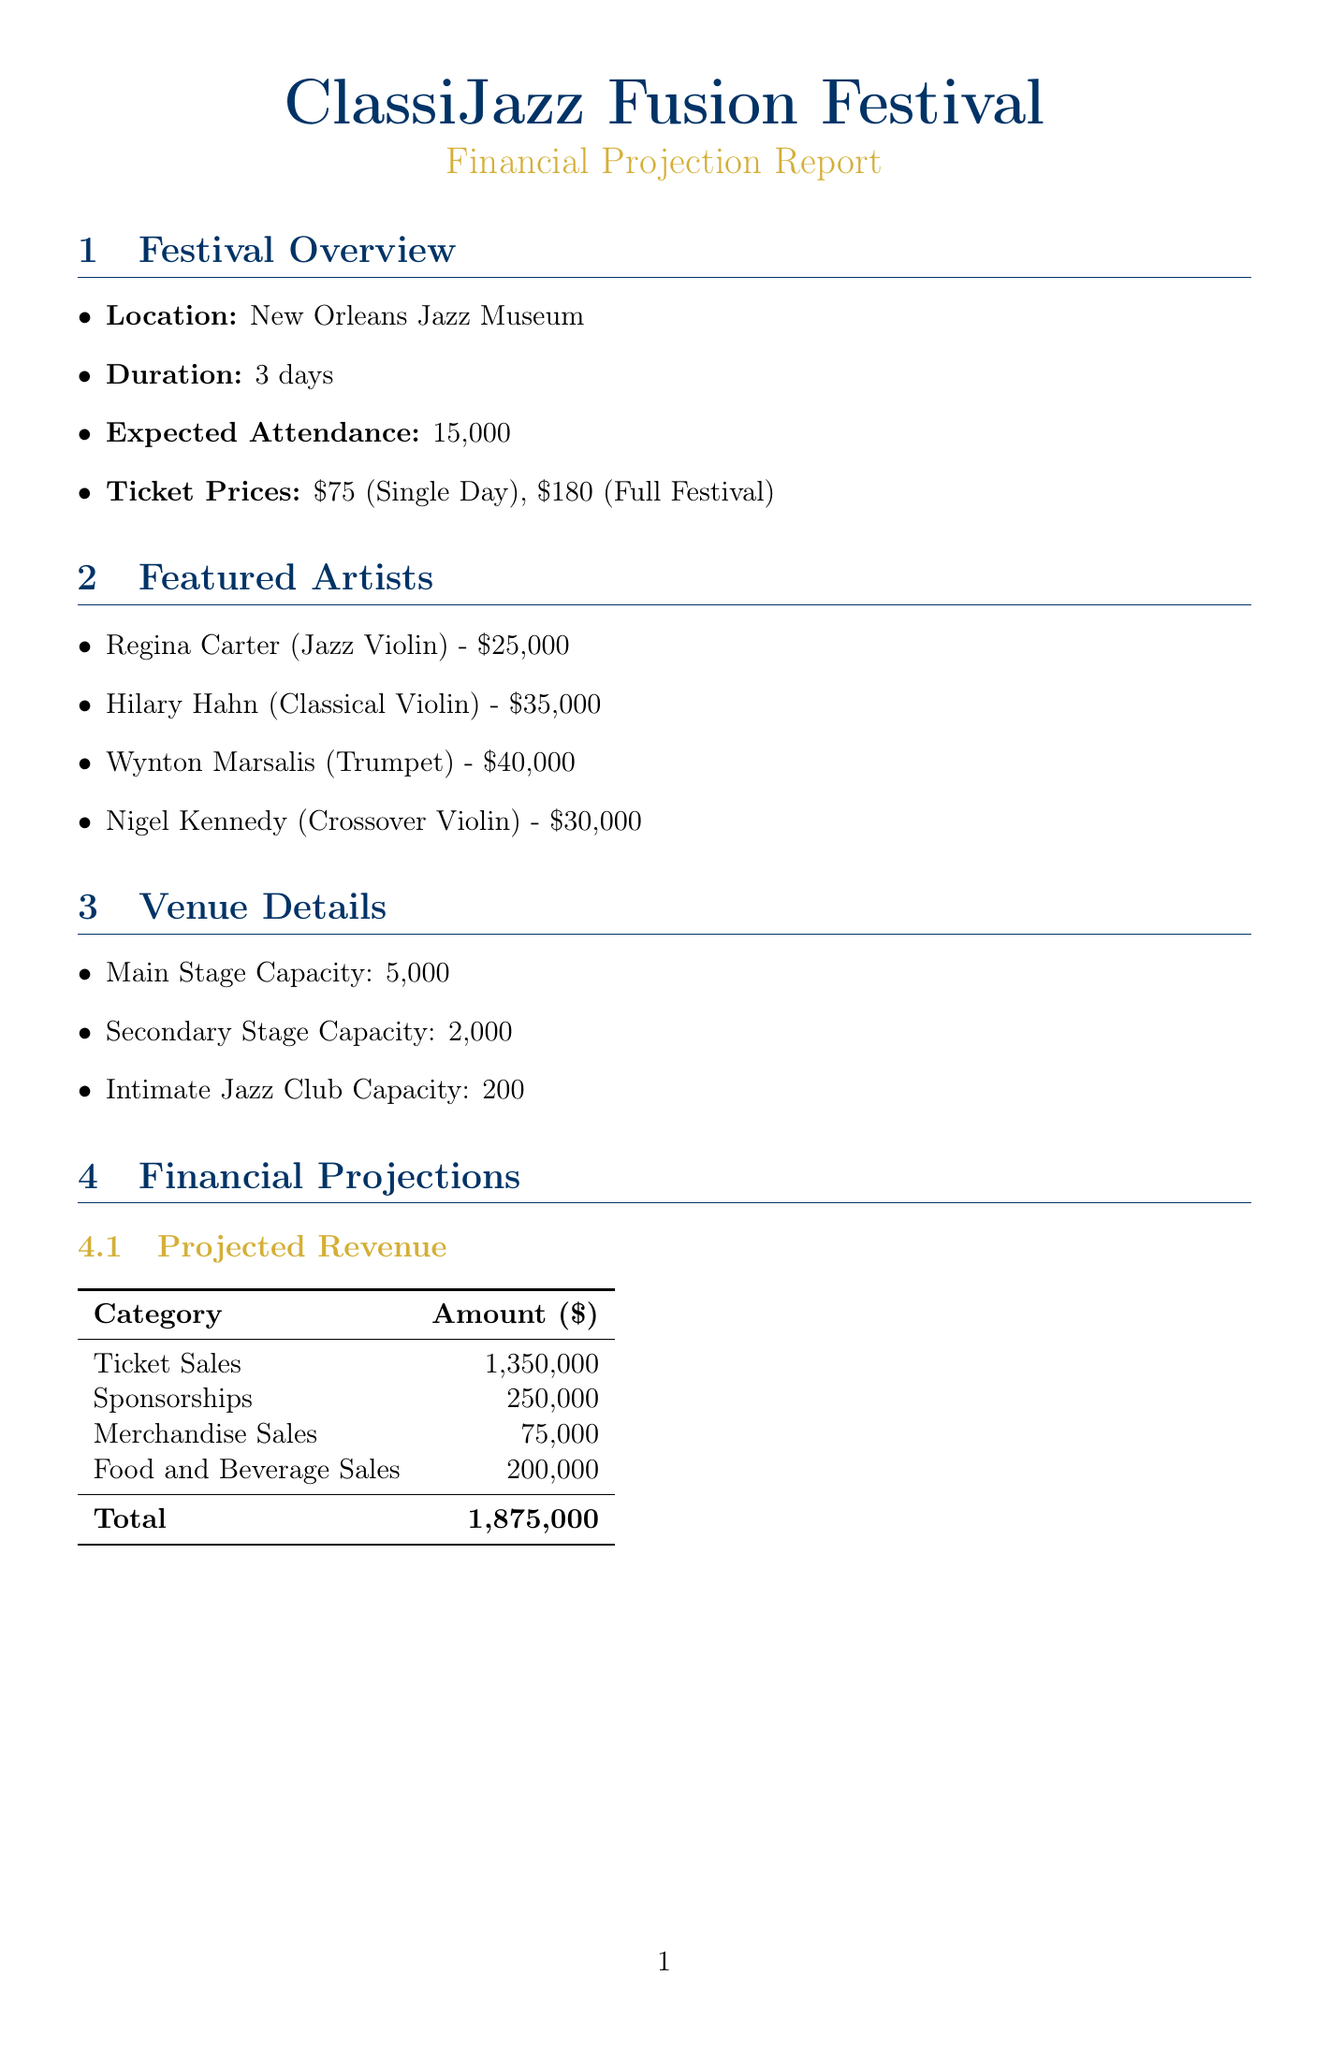What is the location of the festival? The document states that the festival is held at the New Orleans Jazz Museum.
Answer: New Orleans Jazz Museum What is the expected attendance for the festival? The document mentions an expected attendance of 15,000 people.
Answer: 15,000 How much is the fee for Hilary Hahn? Hilary Hahn's fee is listed as $35,000 in the featured artists section.
Answer: $35,000 What is the total projected revenue? The total projected revenue is the sum of all income sources calculated in the document, which is $1,875,000.
Answer: $1,875,000 What contingency is in place for weather-related issues? The document notes that indoor backup venues have been secured as a contingency for weather-related issues.
Answer: Indoor backup venues secured What is the capacity of the secondary stage? The document states that the secondary stage has a capacity of 2,000 attendees.
Answer: 2,000 What initiatives are included in the sustainability plan? The document mentions partnerships for waste reduction, carbon offset, and local sourcing as sustainability initiatives.
Answer: Waste reduction, carbon offset, local sourcing How much will be spent on digital marketing? The document indicates that digital marketing expenses will be $80,000, comprising social media and influencer partnerships.
Answer: $80,000 What is the contribution of Yamaha Music? The document states that Yamaha Music contributes $50,000 and provides instrument sponsorship.
Answer: $50,000 